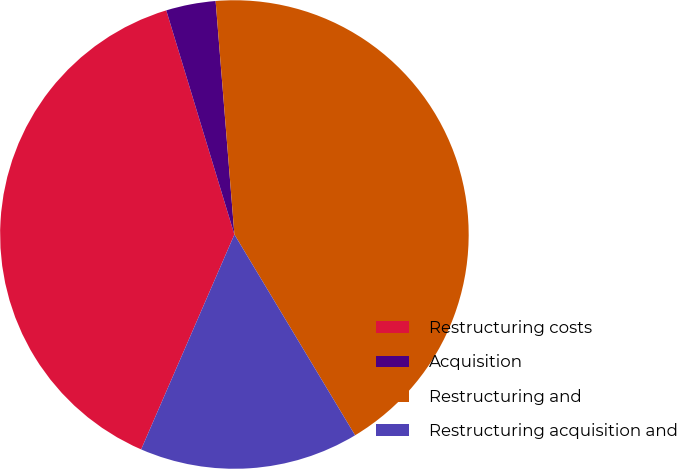Convert chart to OTSL. <chart><loc_0><loc_0><loc_500><loc_500><pie_chart><fcel>Restructuring costs<fcel>Acquisition<fcel>Restructuring and<fcel>Restructuring acquisition and<nl><fcel>38.79%<fcel>3.42%<fcel>42.67%<fcel>15.13%<nl></chart> 